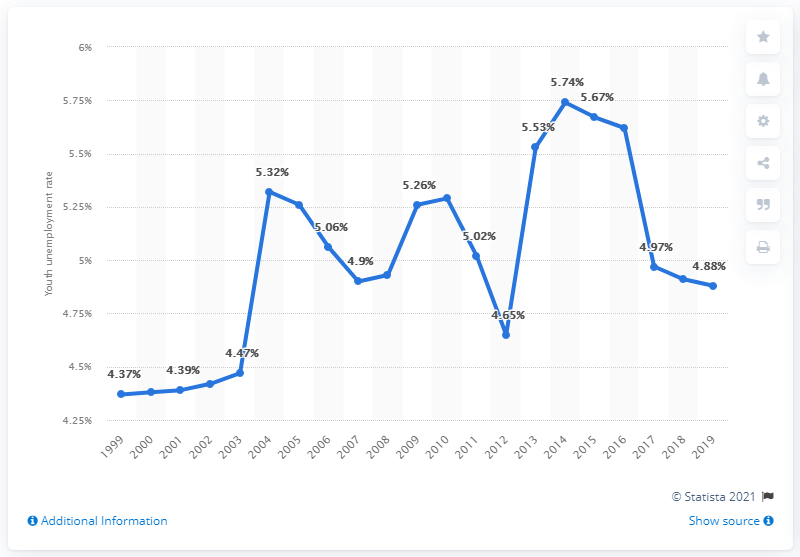Highlight a few significant elements in this photo. In 2019, the youth unemployment rate in Guatemala was 4.88%. 